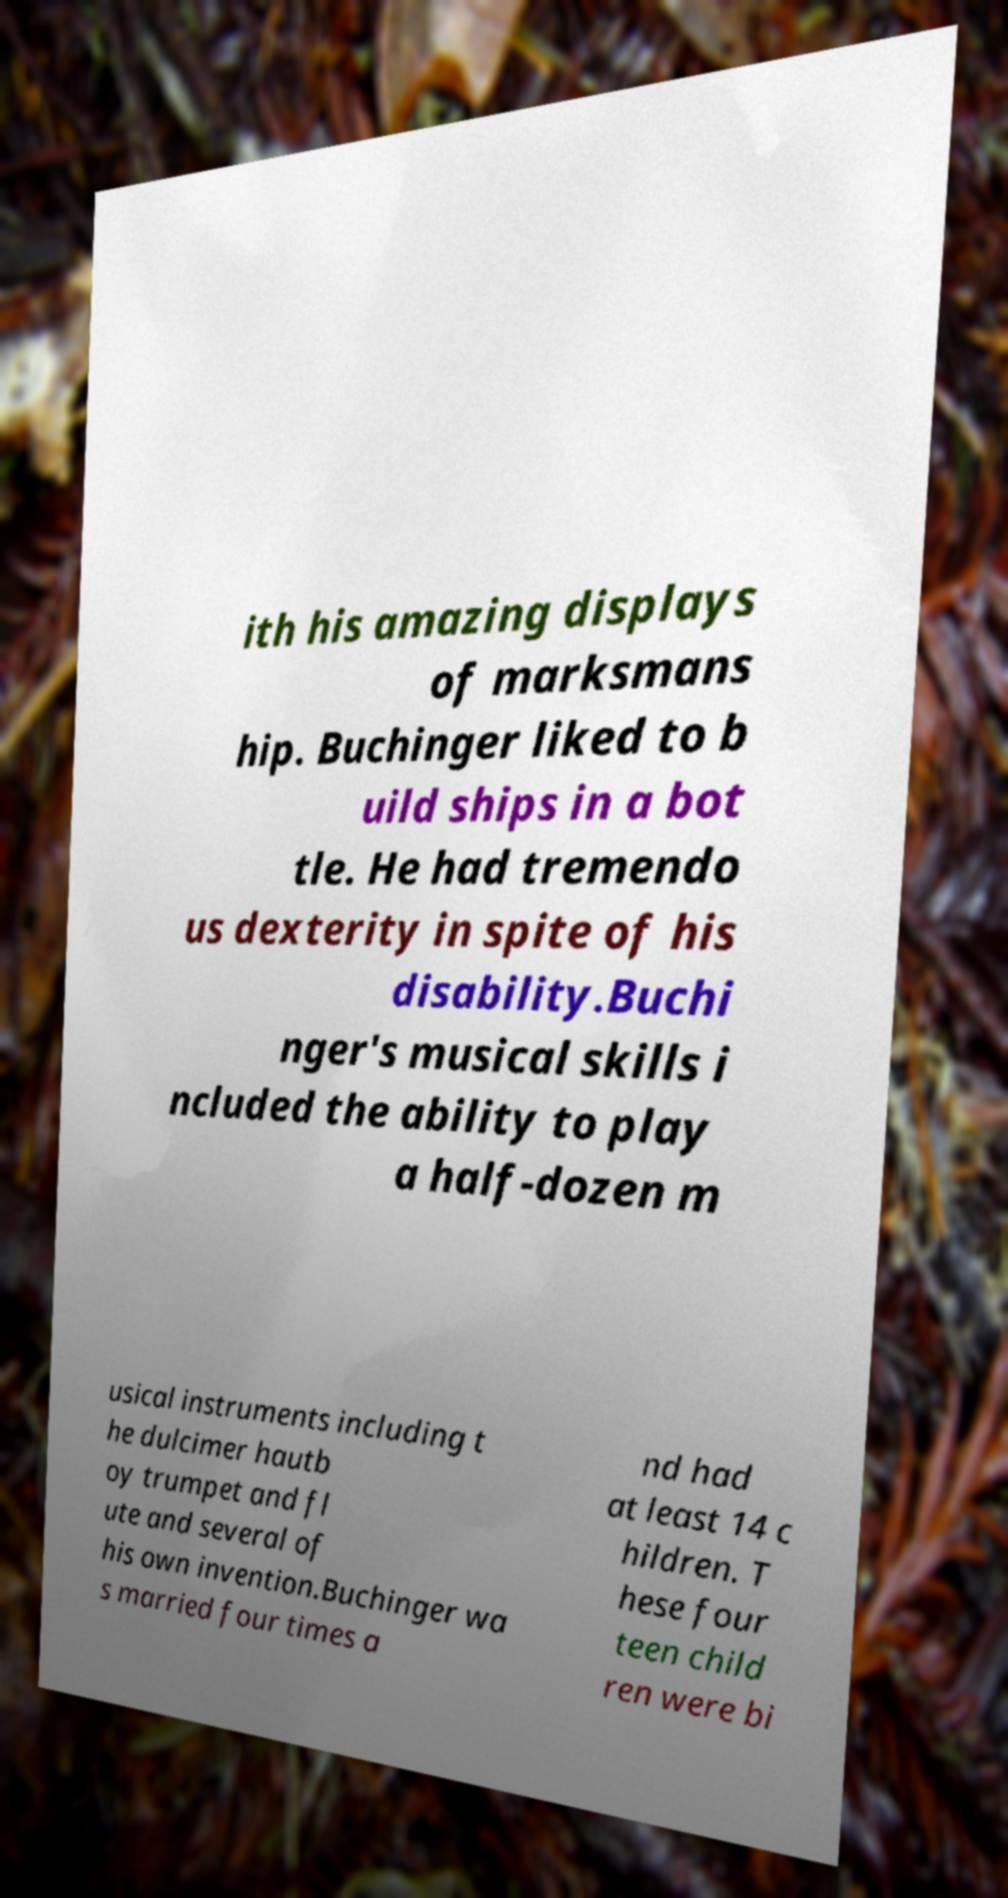Can you read and provide the text displayed in the image?This photo seems to have some interesting text. Can you extract and type it out for me? ith his amazing displays of marksmans hip. Buchinger liked to b uild ships in a bot tle. He had tremendo us dexterity in spite of his disability.Buchi nger's musical skills i ncluded the ability to play a half-dozen m usical instruments including t he dulcimer hautb oy trumpet and fl ute and several of his own invention.Buchinger wa s married four times a nd had at least 14 c hildren. T hese four teen child ren were bi 